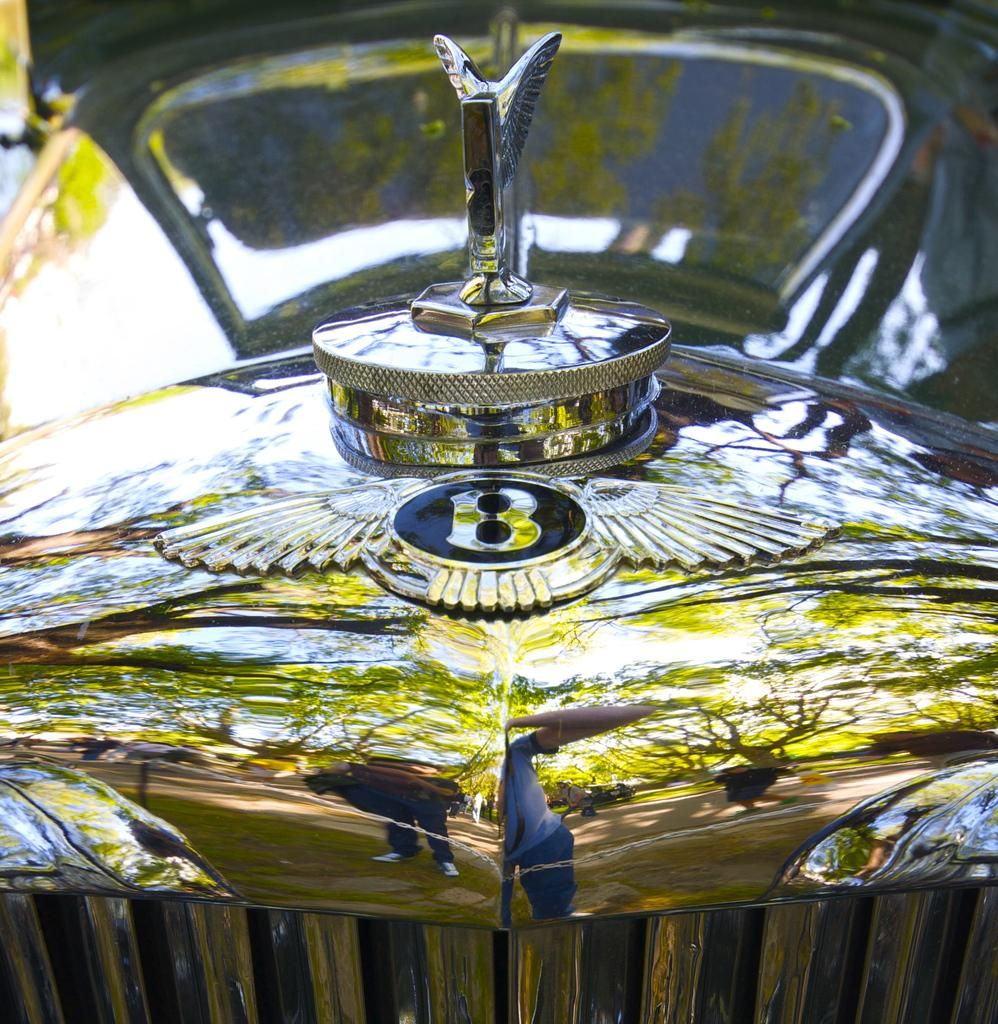What is the main subject of the image? There is a vehicle in the image. What can be seen in the vehicle's surroundings? There are reflections of trees in the image. What part of the natural environment is visible in the image? The sky is visible in the image. Are there any people present in the image? Yes, there are people on the vehicle. What type of mint is being used to decorate the birthday cake in the image? There is no birthday cake or mint present in the image; it features a vehicle with people on it. What type of coach is visible in the image? There is no coach present in the image; it features a vehicle with people on it. 